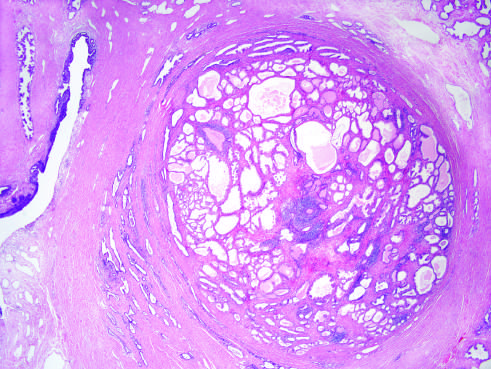does low-power photomicrograph demonstrate a well-demarcated nodule at the right of the field, with a portion of urethra seen to the left?
Answer the question using a single word or phrase. Yes 